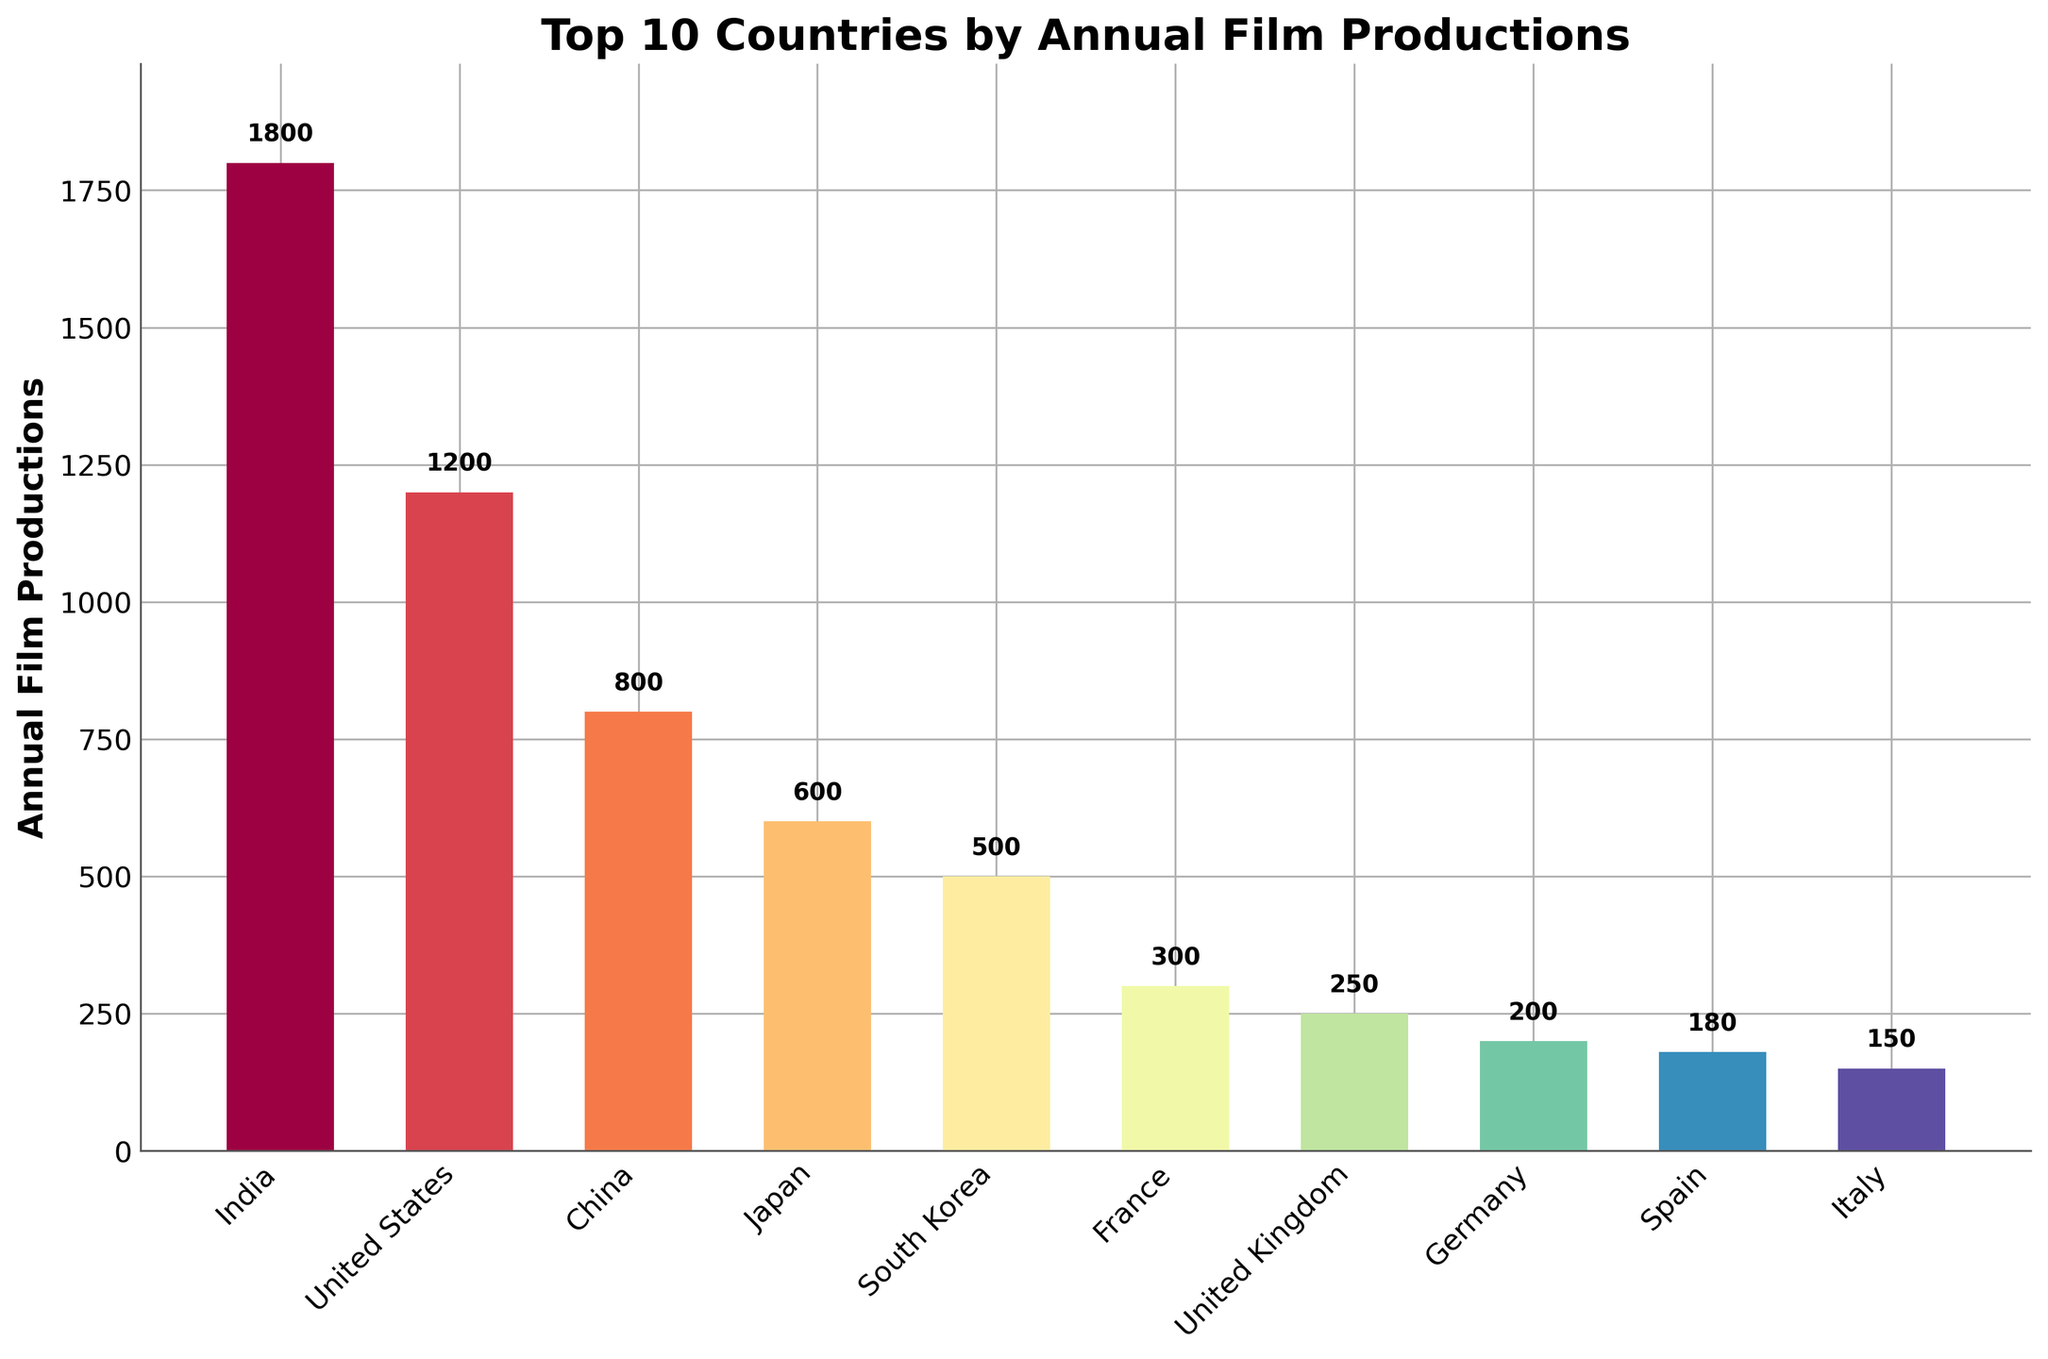Which country has the highest annual film productions? The country with the highest bar represents the highest annual film productions. India has the tallest bar.
Answer: India What is the difference in annual film productions between India and the United States? Subtract the number of productions of the United States from that of India, i.e., 1800 - 1200.
Answer: 600 Which country has fewer annual film productions, France or the United Kingdom? Compare the heights of the bars representing France and the United Kingdom. France has a lower bar at 300 productions compared to the United Kingdom's 250.
Answer: United Kingdom What is the sum of annual film productions for South Korea, France, and Germany? Add the productions of South Korea, France, and Germany: 500 + 300 + 200.
Answer: 1000 How many more films does China produce annually compared to Italy? Subtract the number of productions of Italy from that of China, i.e., 800 - 150.
Answer: 650 What is the average annual film production of the bottom five countries? Add the productions of South Korea, France, United Kingdom, Germany, Spain, and Italy, then divide by 5: (500 + 300 + 250 + 200 + 180 + 150)/5.
Answer: 276 Among the top 10 countries, which one produces the least films annually? Identify the country with the shortest bar. Italy has the shortest bar at 150 productions.
Answer: Italy How many countries produce more than 500 films annually? Count the number of bars that extend beyond the 500 mark. India, United States, China, Japan, and South Korea do.
Answer: 5 Compare the total annual film productions of the top 3 countries to the next 3 countries. Which group produces more films? Calculate the sum for the top 3 countries (India, United States, China) and the next 3 (Japan, South Korea, France). Top 3: 1800 + 1200 + 800 = 3800. Next 3: 600 + 500 + 300 = 1400.
Answer: Top 3 What is the median number of annual film productions for these 10 countries? Arrange the productions in order and find the middle value(s). The ordered sequence is: 150, 180, 200, 250, 300, 500, 600, 800, 1200, 1800. The median is (300 + 500)/2.
Answer: 400 